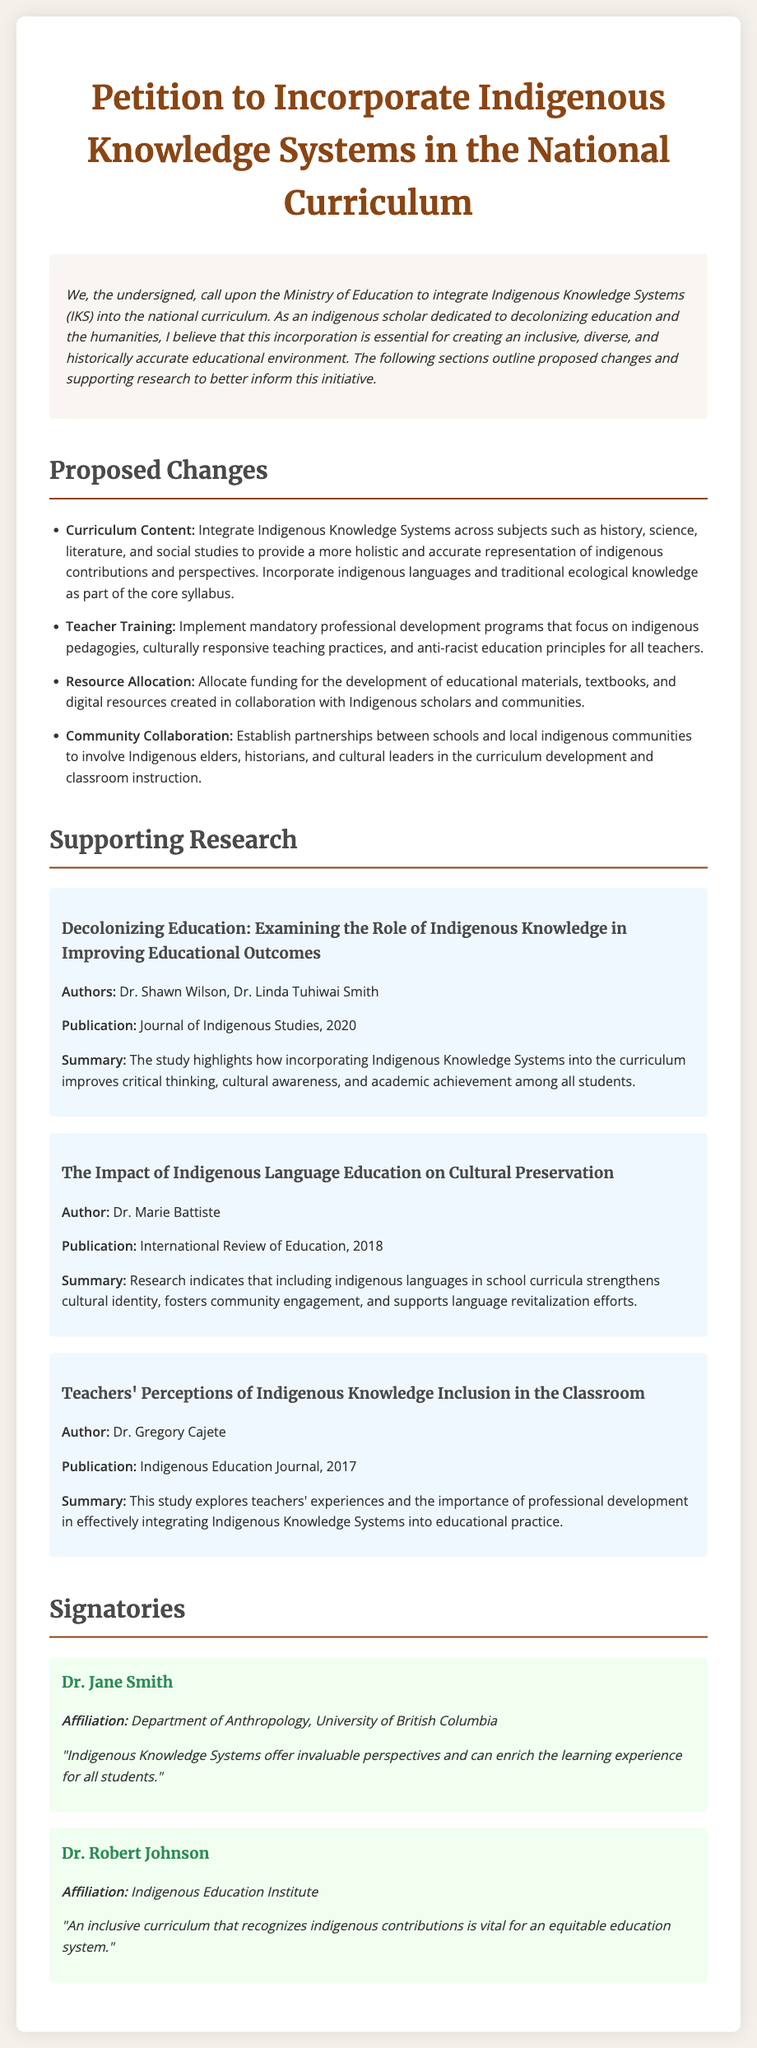What is the title of the petition? The title of the petition is prominently displayed at the top of the document.
Answer: Petition to Incorporate Indigenous Knowledge Systems in the National Curriculum Who are the authors of the first research item? The authors of the first research item are mentioned under the summary of the study in the supporting research section.
Answer: Dr. Shawn Wilson, Dr. Linda Tuhiwai Smith What year was the second research item published? The publication year is stated near the title of the second research item in the supporting research section.
Answer: 2018 What are the four proposed changes listed in the document? The proposed changes are outlined as bullet points under the section "Proposed Changes."
Answer: Curriculum Content, Teacher Training, Resource Allocation, Community Collaboration Which institute is Dr. Robert Johnson affiliated with? Dr. Robert Johnson's affiliation is provided in the signatories section of the document.
Answer: Indigenous Education Institute How many research items are presented in the supporting research section? The number of research items is determined by counting the sections included under "Supporting Research."
Answer: Three 